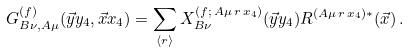<formula> <loc_0><loc_0><loc_500><loc_500>G ^ { ( f ) } _ { B \nu , A \mu } ( \vec { y } y _ { 4 } , \vec { x } x _ { 4 } ) = \sum _ { \langle r \rangle } X ^ { ( f ; \, A \mu \, r \, x _ { 4 } ) } _ { B \nu } ( \vec { y } y _ { 4 } ) R ^ { ( A \mu \, r \, x _ { 4 } ) \ast } ( \vec { x } ) \, .</formula> 